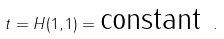Convert formula to latex. <formula><loc_0><loc_0><loc_500><loc_500>t = H ( 1 , 1 ) = \text {constant} \ .</formula> 